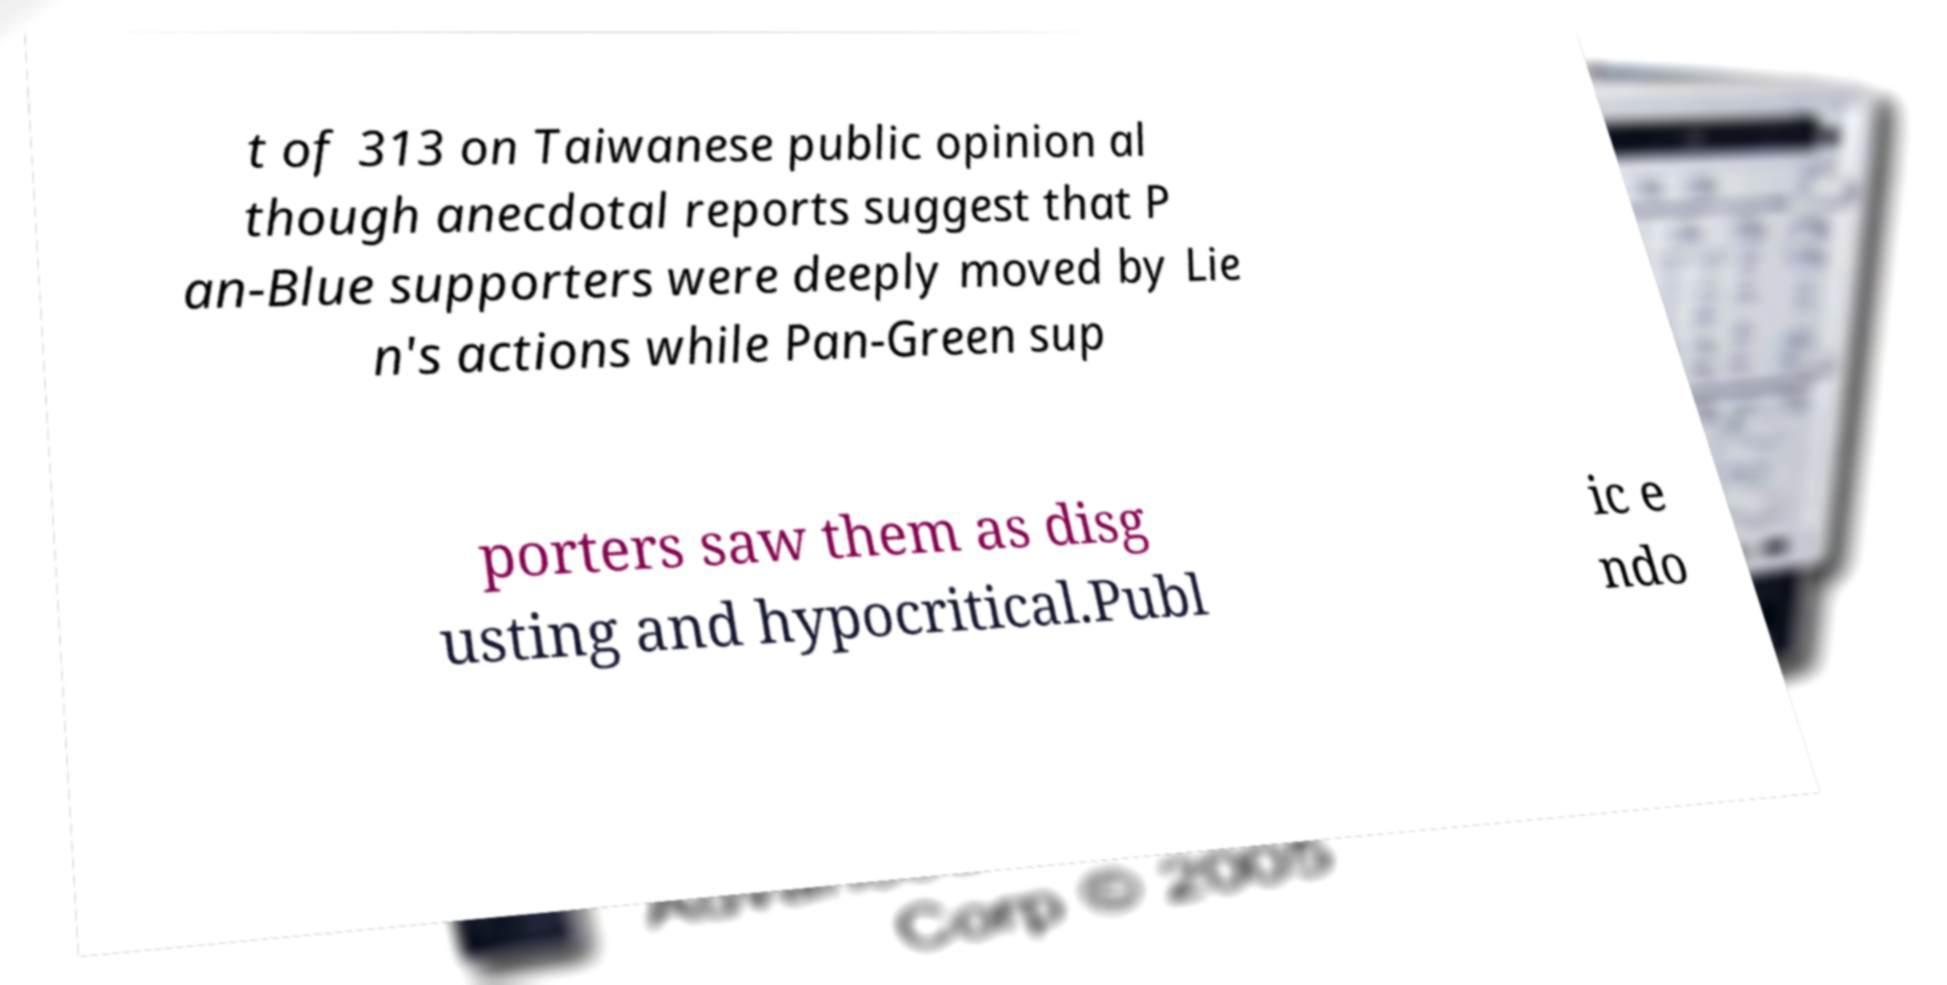For documentation purposes, I need the text within this image transcribed. Could you provide that? t of 313 on Taiwanese public opinion al though anecdotal reports suggest that P an-Blue supporters were deeply moved by Lie n's actions while Pan-Green sup porters saw them as disg usting and hypocritical.Publ ic e ndo 